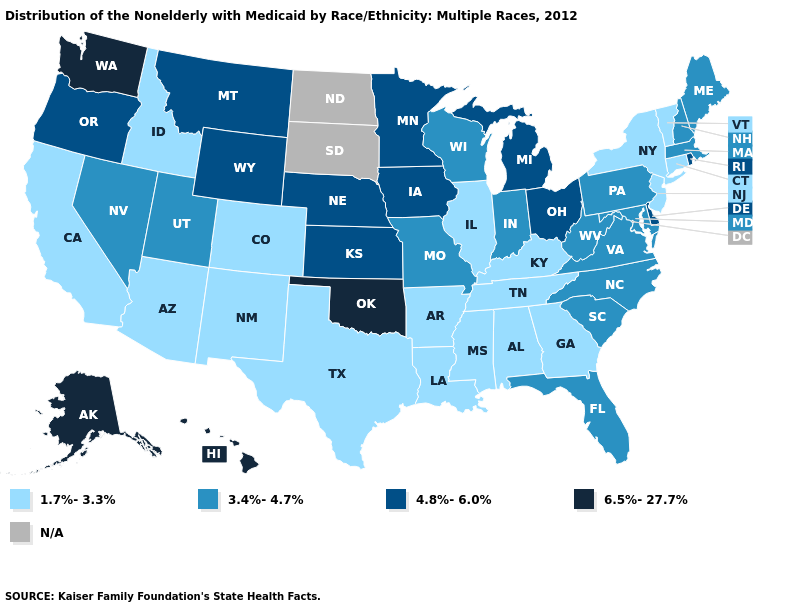Among the states that border Kentucky , does Indiana have the lowest value?
Concise answer only. No. Name the states that have a value in the range 4.8%-6.0%?
Write a very short answer. Delaware, Iowa, Kansas, Michigan, Minnesota, Montana, Nebraska, Ohio, Oregon, Rhode Island, Wyoming. Does Alabama have the lowest value in the USA?
Quick response, please. Yes. What is the highest value in the Northeast ?
Quick response, please. 4.8%-6.0%. What is the lowest value in states that border Ohio?
Be succinct. 1.7%-3.3%. What is the value of Wyoming?
Answer briefly. 4.8%-6.0%. Name the states that have a value in the range N/A?
Concise answer only. North Dakota, South Dakota. What is the lowest value in the USA?
Short answer required. 1.7%-3.3%. Name the states that have a value in the range 6.5%-27.7%?
Concise answer only. Alaska, Hawaii, Oklahoma, Washington. What is the value of North Carolina?
Keep it brief. 3.4%-4.7%. Does Tennessee have the lowest value in the USA?
Write a very short answer. Yes. What is the value of Wyoming?
Keep it brief. 4.8%-6.0%. Which states hav the highest value in the MidWest?
Be succinct. Iowa, Kansas, Michigan, Minnesota, Nebraska, Ohio. Does the first symbol in the legend represent the smallest category?
Answer briefly. Yes. Name the states that have a value in the range 1.7%-3.3%?
Be succinct. Alabama, Arizona, Arkansas, California, Colorado, Connecticut, Georgia, Idaho, Illinois, Kentucky, Louisiana, Mississippi, New Jersey, New Mexico, New York, Tennessee, Texas, Vermont. 